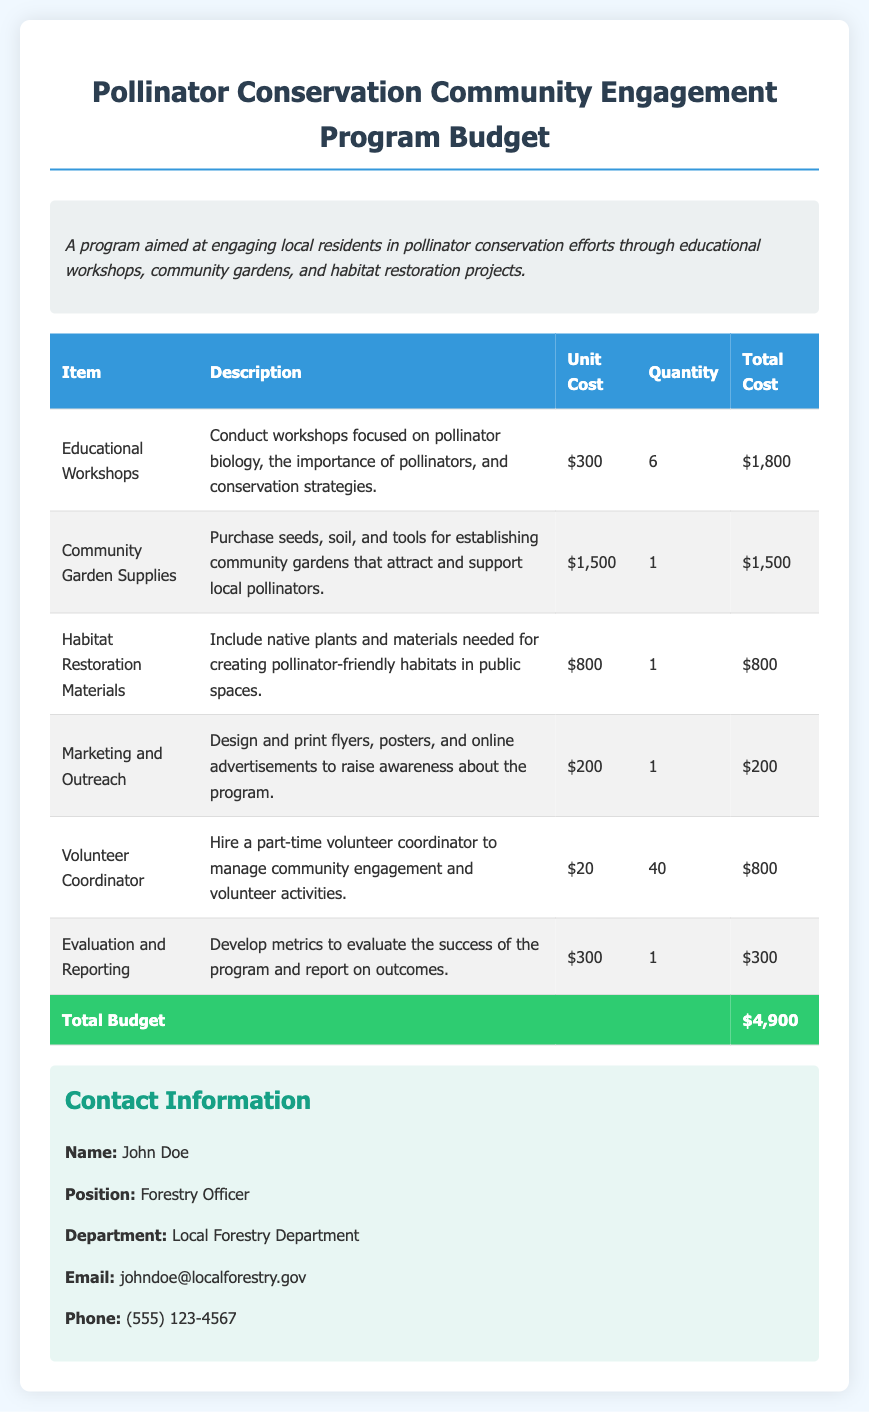What is the total budget? The total budget is the sum of all the costs listed in the document, which is $4,900.
Answer: $4,900 How many educational workshops are planned? The document states that there will be 6 educational workshops conducted.
Answer: 6 What is the unit cost for the Community Garden Supplies? The unit cost for Community Garden Supplies is specified as $1,500 in the budget.
Answer: $1,500 Who is the volunteer coordinator? The document mentions hiring a part-time volunteer coordinator for managing community engagement activities.
Answer: Part-time volunteer coordinator What is included in the Habitat Restoration Materials? The description states that it includes native plants and materials needed for creating pollinator-friendly habitats.
Answer: Native plants and materials What is the purpose of the Marketing and Outreach item? The document explains that the purpose is to design and print materials to raise awareness about the program.
Answer: Raise awareness How many metrics will be developed for evaluation? The document indicates that developing metrics for evaluating the success of the program is part of the budget, but does not specify a number.
Answer: 1 What type of program is being proposed? The document describes a program aimed at engaging local residents in pollinator conservation efforts.
Answer: Pollinator conservation What is the total unit cost for Volunteer Coordinator? The document lists the unit cost for the Volunteer Coordinator as $20.
Answer: $20 